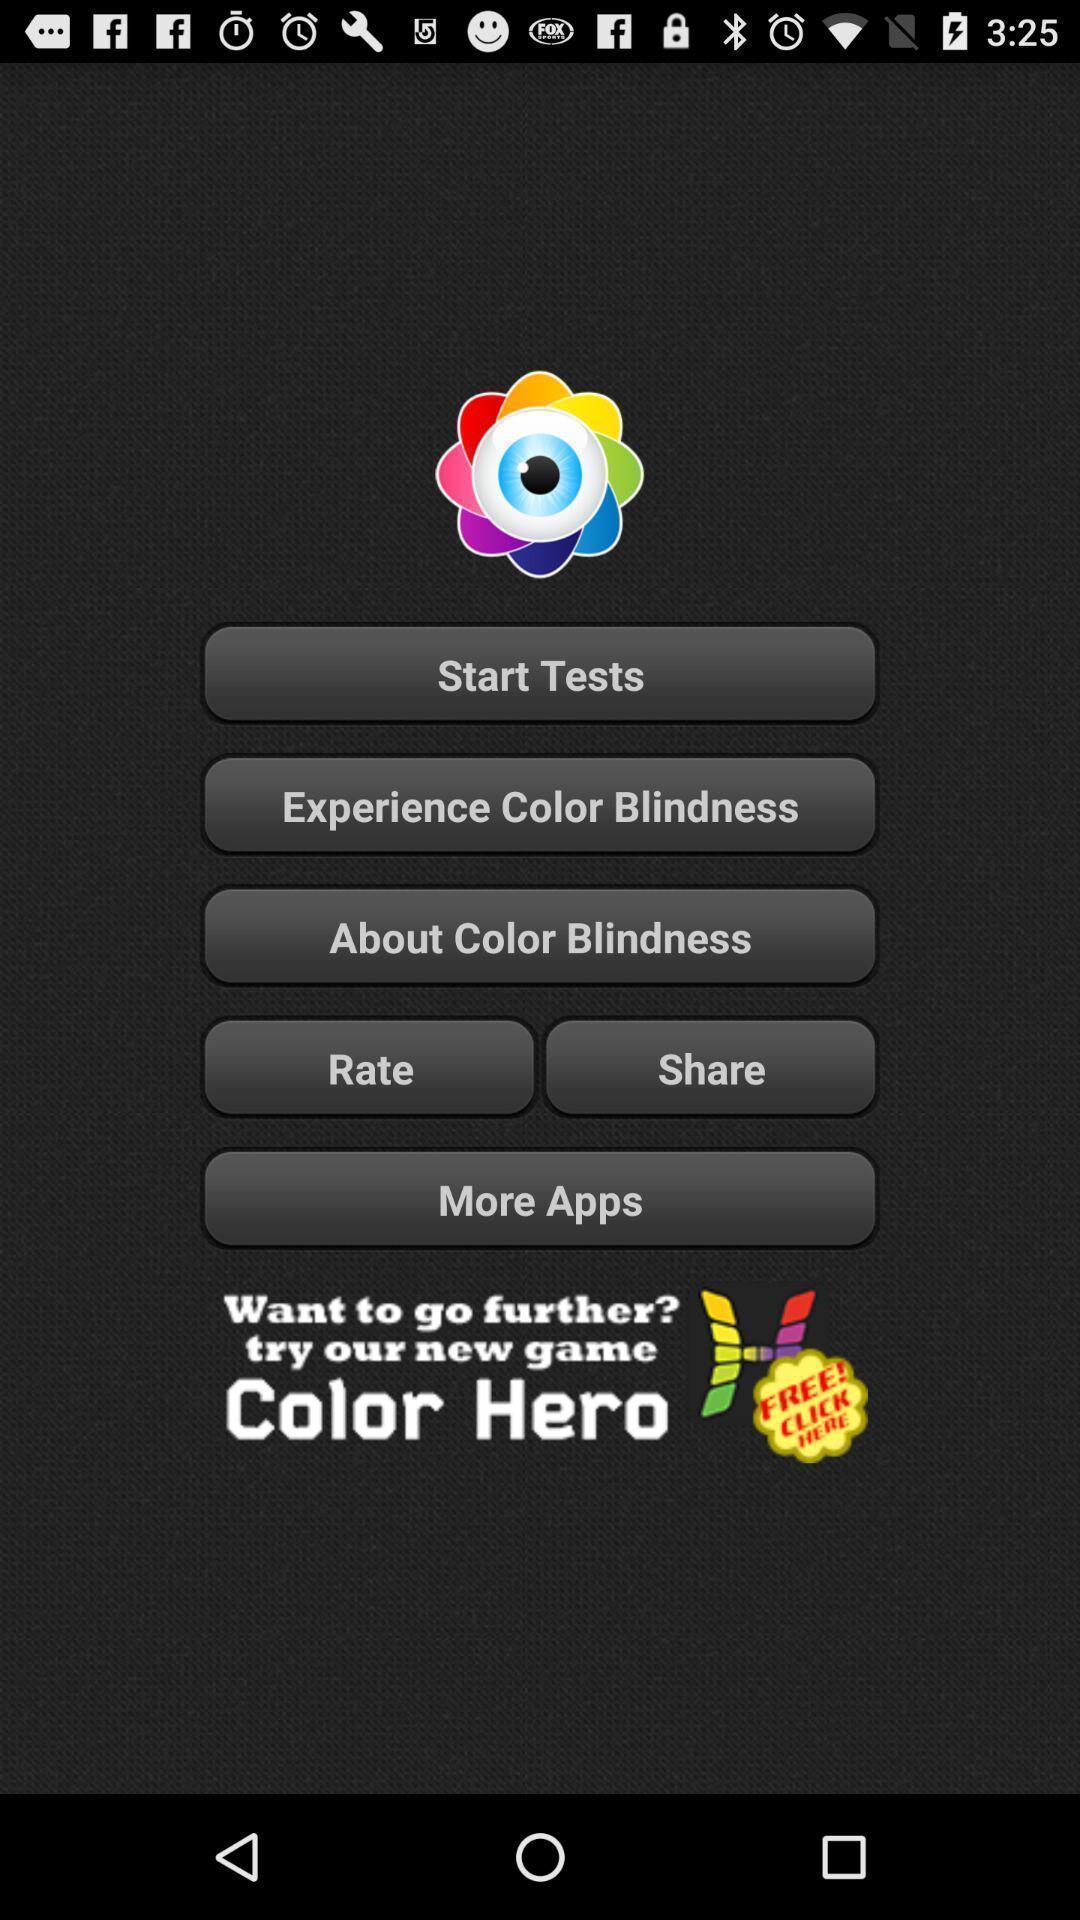What can you discern from this picture? Screen showing a test of color blindness. 